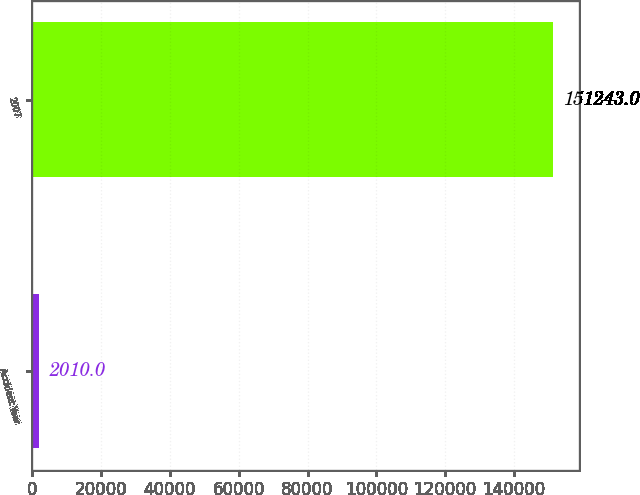Convert chart to OTSL. <chart><loc_0><loc_0><loc_500><loc_500><bar_chart><fcel>Accident Year<fcel>2007<nl><fcel>2010<fcel>151243<nl></chart> 